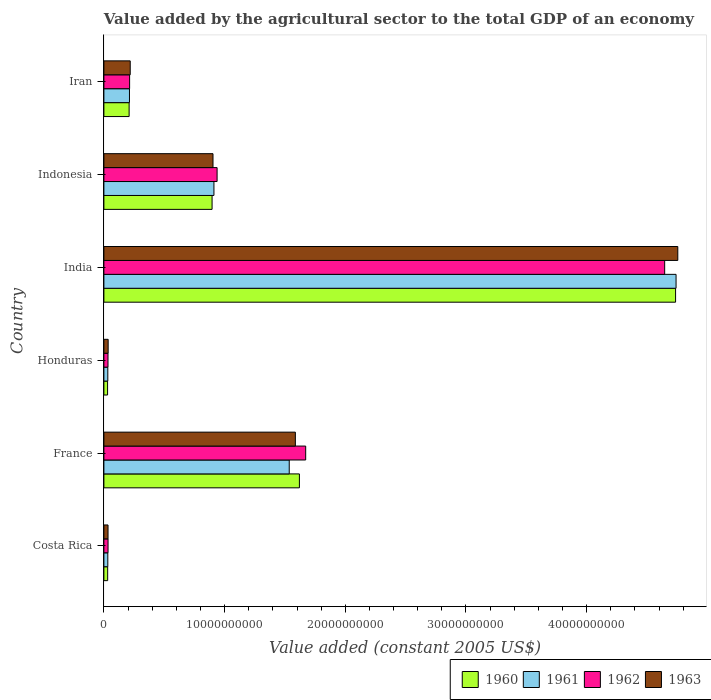How many groups of bars are there?
Offer a very short reply. 6. Are the number of bars on each tick of the Y-axis equal?
Your answer should be very brief. Yes. How many bars are there on the 6th tick from the top?
Your answer should be compact. 4. How many bars are there on the 4th tick from the bottom?
Your answer should be compact. 4. What is the label of the 3rd group of bars from the top?
Your answer should be compact. India. What is the value added by the agricultural sector in 1963 in Iran?
Provide a short and direct response. 2.18e+09. Across all countries, what is the maximum value added by the agricultural sector in 1962?
Offer a terse response. 4.65e+1. Across all countries, what is the minimum value added by the agricultural sector in 1963?
Your response must be concise. 3.43e+08. In which country was the value added by the agricultural sector in 1961 minimum?
Give a very brief answer. Costa Rica. What is the total value added by the agricultural sector in 1961 in the graph?
Your response must be concise. 7.47e+1. What is the difference between the value added by the agricultural sector in 1962 in India and that in Indonesia?
Provide a short and direct response. 3.71e+1. What is the difference between the value added by the agricultural sector in 1961 in Honduras and the value added by the agricultural sector in 1960 in Indonesia?
Offer a very short reply. -8.64e+09. What is the average value added by the agricultural sector in 1962 per country?
Your response must be concise. 1.26e+1. What is the difference between the value added by the agricultural sector in 1962 and value added by the agricultural sector in 1960 in Honduras?
Offer a very short reply. 3.54e+07. In how many countries, is the value added by the agricultural sector in 1963 greater than 8000000000 US$?
Ensure brevity in your answer.  3. What is the ratio of the value added by the agricultural sector in 1961 in Costa Rica to that in India?
Offer a terse response. 0.01. Is the difference between the value added by the agricultural sector in 1962 in Honduras and India greater than the difference between the value added by the agricultural sector in 1960 in Honduras and India?
Make the answer very short. Yes. What is the difference between the highest and the second highest value added by the agricultural sector in 1962?
Your answer should be compact. 2.97e+1. What is the difference between the highest and the lowest value added by the agricultural sector in 1962?
Provide a succinct answer. 4.61e+1. Is the sum of the value added by the agricultural sector in 1962 in Costa Rica and Indonesia greater than the maximum value added by the agricultural sector in 1961 across all countries?
Ensure brevity in your answer.  No. Is it the case that in every country, the sum of the value added by the agricultural sector in 1963 and value added by the agricultural sector in 1961 is greater than the sum of value added by the agricultural sector in 1962 and value added by the agricultural sector in 1960?
Provide a short and direct response. No. What does the 4th bar from the bottom in Costa Rica represents?
Keep it short and to the point. 1963. Is it the case that in every country, the sum of the value added by the agricultural sector in 1962 and value added by the agricultural sector in 1960 is greater than the value added by the agricultural sector in 1961?
Give a very brief answer. Yes. Are all the bars in the graph horizontal?
Keep it short and to the point. Yes. What is the difference between two consecutive major ticks on the X-axis?
Make the answer very short. 1.00e+1. Are the values on the major ticks of X-axis written in scientific E-notation?
Offer a very short reply. No. Does the graph contain any zero values?
Your answer should be compact. No. Does the graph contain grids?
Offer a terse response. No. Where does the legend appear in the graph?
Offer a terse response. Bottom right. How are the legend labels stacked?
Keep it short and to the point. Horizontal. What is the title of the graph?
Provide a succinct answer. Value added by the agricultural sector to the total GDP of an economy. Does "1999" appear as one of the legend labels in the graph?
Keep it short and to the point. No. What is the label or title of the X-axis?
Your answer should be compact. Value added (constant 2005 US$). What is the Value added (constant 2005 US$) of 1960 in Costa Rica?
Your answer should be compact. 3.13e+08. What is the Value added (constant 2005 US$) of 1961 in Costa Rica?
Make the answer very short. 3.24e+08. What is the Value added (constant 2005 US$) in 1962 in Costa Rica?
Provide a short and direct response. 3.44e+08. What is the Value added (constant 2005 US$) of 1963 in Costa Rica?
Ensure brevity in your answer.  3.43e+08. What is the Value added (constant 2005 US$) of 1960 in France?
Your response must be concise. 1.62e+1. What is the Value added (constant 2005 US$) in 1961 in France?
Offer a very short reply. 1.54e+1. What is the Value added (constant 2005 US$) of 1962 in France?
Provide a succinct answer. 1.67e+1. What is the Value added (constant 2005 US$) in 1963 in France?
Provide a succinct answer. 1.59e+1. What is the Value added (constant 2005 US$) of 1960 in Honduras?
Provide a succinct answer. 3.05e+08. What is the Value added (constant 2005 US$) in 1961 in Honduras?
Make the answer very short. 3.25e+08. What is the Value added (constant 2005 US$) in 1962 in Honduras?
Offer a terse response. 3.41e+08. What is the Value added (constant 2005 US$) of 1963 in Honduras?
Offer a very short reply. 3.53e+08. What is the Value added (constant 2005 US$) of 1960 in India?
Offer a terse response. 4.74e+1. What is the Value added (constant 2005 US$) of 1961 in India?
Keep it short and to the point. 4.74e+1. What is the Value added (constant 2005 US$) of 1962 in India?
Ensure brevity in your answer.  4.65e+1. What is the Value added (constant 2005 US$) of 1963 in India?
Keep it short and to the point. 4.76e+1. What is the Value added (constant 2005 US$) in 1960 in Indonesia?
Ensure brevity in your answer.  8.96e+09. What is the Value added (constant 2005 US$) in 1961 in Indonesia?
Offer a terse response. 9.12e+09. What is the Value added (constant 2005 US$) of 1962 in Indonesia?
Ensure brevity in your answer.  9.38e+09. What is the Value added (constant 2005 US$) in 1963 in Indonesia?
Give a very brief answer. 9.04e+09. What is the Value added (constant 2005 US$) in 1960 in Iran?
Offer a very short reply. 2.09e+09. What is the Value added (constant 2005 US$) in 1961 in Iran?
Provide a short and direct response. 2.12e+09. What is the Value added (constant 2005 US$) of 1962 in Iran?
Offer a terse response. 2.13e+09. What is the Value added (constant 2005 US$) in 1963 in Iran?
Provide a short and direct response. 2.18e+09. Across all countries, what is the maximum Value added (constant 2005 US$) in 1960?
Your response must be concise. 4.74e+1. Across all countries, what is the maximum Value added (constant 2005 US$) in 1961?
Ensure brevity in your answer.  4.74e+1. Across all countries, what is the maximum Value added (constant 2005 US$) in 1962?
Your answer should be very brief. 4.65e+1. Across all countries, what is the maximum Value added (constant 2005 US$) in 1963?
Your answer should be compact. 4.76e+1. Across all countries, what is the minimum Value added (constant 2005 US$) of 1960?
Your answer should be compact. 3.05e+08. Across all countries, what is the minimum Value added (constant 2005 US$) of 1961?
Your answer should be compact. 3.24e+08. Across all countries, what is the minimum Value added (constant 2005 US$) in 1962?
Ensure brevity in your answer.  3.41e+08. Across all countries, what is the minimum Value added (constant 2005 US$) in 1963?
Your response must be concise. 3.43e+08. What is the total Value added (constant 2005 US$) in 1960 in the graph?
Your answer should be very brief. 7.52e+1. What is the total Value added (constant 2005 US$) of 1961 in the graph?
Make the answer very short. 7.47e+1. What is the total Value added (constant 2005 US$) in 1962 in the graph?
Provide a succinct answer. 7.54e+1. What is the total Value added (constant 2005 US$) in 1963 in the graph?
Ensure brevity in your answer.  7.53e+1. What is the difference between the Value added (constant 2005 US$) of 1960 in Costa Rica and that in France?
Ensure brevity in your answer.  -1.59e+1. What is the difference between the Value added (constant 2005 US$) of 1961 in Costa Rica and that in France?
Provide a succinct answer. -1.50e+1. What is the difference between the Value added (constant 2005 US$) of 1962 in Costa Rica and that in France?
Provide a short and direct response. -1.64e+1. What is the difference between the Value added (constant 2005 US$) of 1963 in Costa Rica and that in France?
Your answer should be very brief. -1.55e+1. What is the difference between the Value added (constant 2005 US$) of 1960 in Costa Rica and that in Honduras?
Keep it short and to the point. 7.61e+06. What is the difference between the Value added (constant 2005 US$) in 1961 in Costa Rica and that in Honduras?
Provide a short and direct response. -8.14e+05. What is the difference between the Value added (constant 2005 US$) in 1962 in Costa Rica and that in Honduras?
Your answer should be compact. 3.61e+06. What is the difference between the Value added (constant 2005 US$) of 1963 in Costa Rica and that in Honduras?
Your answer should be compact. -9.78e+06. What is the difference between the Value added (constant 2005 US$) in 1960 in Costa Rica and that in India?
Your answer should be very brief. -4.71e+1. What is the difference between the Value added (constant 2005 US$) of 1961 in Costa Rica and that in India?
Give a very brief answer. -4.71e+1. What is the difference between the Value added (constant 2005 US$) in 1962 in Costa Rica and that in India?
Offer a very short reply. -4.61e+1. What is the difference between the Value added (constant 2005 US$) of 1963 in Costa Rica and that in India?
Make the answer very short. -4.72e+1. What is the difference between the Value added (constant 2005 US$) in 1960 in Costa Rica and that in Indonesia?
Your response must be concise. -8.65e+09. What is the difference between the Value added (constant 2005 US$) in 1961 in Costa Rica and that in Indonesia?
Provide a short and direct response. -8.79e+09. What is the difference between the Value added (constant 2005 US$) of 1962 in Costa Rica and that in Indonesia?
Give a very brief answer. -9.03e+09. What is the difference between the Value added (constant 2005 US$) in 1963 in Costa Rica and that in Indonesia?
Provide a short and direct response. -8.70e+09. What is the difference between the Value added (constant 2005 US$) of 1960 in Costa Rica and that in Iran?
Offer a terse response. -1.78e+09. What is the difference between the Value added (constant 2005 US$) in 1961 in Costa Rica and that in Iran?
Your answer should be very brief. -1.80e+09. What is the difference between the Value added (constant 2005 US$) in 1962 in Costa Rica and that in Iran?
Your answer should be very brief. -1.79e+09. What is the difference between the Value added (constant 2005 US$) of 1963 in Costa Rica and that in Iran?
Your answer should be compact. -1.84e+09. What is the difference between the Value added (constant 2005 US$) of 1960 in France and that in Honduras?
Your answer should be very brief. 1.59e+1. What is the difference between the Value added (constant 2005 US$) in 1961 in France and that in Honduras?
Provide a succinct answer. 1.50e+1. What is the difference between the Value added (constant 2005 US$) in 1962 in France and that in Honduras?
Provide a succinct answer. 1.64e+1. What is the difference between the Value added (constant 2005 US$) of 1963 in France and that in Honduras?
Ensure brevity in your answer.  1.55e+1. What is the difference between the Value added (constant 2005 US$) in 1960 in France and that in India?
Offer a terse response. -3.12e+1. What is the difference between the Value added (constant 2005 US$) in 1961 in France and that in India?
Offer a terse response. -3.21e+1. What is the difference between the Value added (constant 2005 US$) in 1962 in France and that in India?
Provide a short and direct response. -2.97e+1. What is the difference between the Value added (constant 2005 US$) of 1963 in France and that in India?
Keep it short and to the point. -3.17e+1. What is the difference between the Value added (constant 2005 US$) in 1960 in France and that in Indonesia?
Provide a succinct answer. 7.24e+09. What is the difference between the Value added (constant 2005 US$) of 1961 in France and that in Indonesia?
Your answer should be very brief. 6.24e+09. What is the difference between the Value added (constant 2005 US$) of 1962 in France and that in Indonesia?
Your answer should be compact. 7.34e+09. What is the difference between the Value added (constant 2005 US$) of 1963 in France and that in Indonesia?
Your response must be concise. 6.82e+09. What is the difference between the Value added (constant 2005 US$) in 1960 in France and that in Iran?
Offer a terse response. 1.41e+1. What is the difference between the Value added (constant 2005 US$) of 1961 in France and that in Iran?
Give a very brief answer. 1.32e+1. What is the difference between the Value added (constant 2005 US$) in 1962 in France and that in Iran?
Your answer should be very brief. 1.46e+1. What is the difference between the Value added (constant 2005 US$) of 1963 in France and that in Iran?
Give a very brief answer. 1.37e+1. What is the difference between the Value added (constant 2005 US$) in 1960 in Honduras and that in India?
Offer a terse response. -4.71e+1. What is the difference between the Value added (constant 2005 US$) of 1961 in Honduras and that in India?
Your answer should be compact. -4.71e+1. What is the difference between the Value added (constant 2005 US$) of 1962 in Honduras and that in India?
Keep it short and to the point. -4.61e+1. What is the difference between the Value added (constant 2005 US$) of 1963 in Honduras and that in India?
Offer a terse response. -4.72e+1. What is the difference between the Value added (constant 2005 US$) in 1960 in Honduras and that in Indonesia?
Your response must be concise. -8.66e+09. What is the difference between the Value added (constant 2005 US$) in 1961 in Honduras and that in Indonesia?
Ensure brevity in your answer.  -8.79e+09. What is the difference between the Value added (constant 2005 US$) of 1962 in Honduras and that in Indonesia?
Make the answer very short. -9.04e+09. What is the difference between the Value added (constant 2005 US$) of 1963 in Honduras and that in Indonesia?
Provide a succinct answer. -8.69e+09. What is the difference between the Value added (constant 2005 US$) of 1960 in Honduras and that in Iran?
Make the answer very short. -1.79e+09. What is the difference between the Value added (constant 2005 US$) of 1961 in Honduras and that in Iran?
Your answer should be compact. -1.79e+09. What is the difference between the Value added (constant 2005 US$) in 1962 in Honduras and that in Iran?
Your answer should be very brief. -1.79e+09. What is the difference between the Value added (constant 2005 US$) in 1963 in Honduras and that in Iran?
Give a very brief answer. -1.83e+09. What is the difference between the Value added (constant 2005 US$) of 1960 in India and that in Indonesia?
Your answer should be compact. 3.84e+1. What is the difference between the Value added (constant 2005 US$) in 1961 in India and that in Indonesia?
Ensure brevity in your answer.  3.83e+1. What is the difference between the Value added (constant 2005 US$) of 1962 in India and that in Indonesia?
Provide a short and direct response. 3.71e+1. What is the difference between the Value added (constant 2005 US$) of 1963 in India and that in Indonesia?
Ensure brevity in your answer.  3.85e+1. What is the difference between the Value added (constant 2005 US$) in 1960 in India and that in Iran?
Keep it short and to the point. 4.53e+1. What is the difference between the Value added (constant 2005 US$) in 1961 in India and that in Iran?
Offer a terse response. 4.53e+1. What is the difference between the Value added (constant 2005 US$) in 1962 in India and that in Iran?
Make the answer very short. 4.43e+1. What is the difference between the Value added (constant 2005 US$) of 1963 in India and that in Iran?
Ensure brevity in your answer.  4.54e+1. What is the difference between the Value added (constant 2005 US$) in 1960 in Indonesia and that in Iran?
Provide a succinct answer. 6.87e+09. What is the difference between the Value added (constant 2005 US$) in 1961 in Indonesia and that in Iran?
Provide a succinct answer. 7.00e+09. What is the difference between the Value added (constant 2005 US$) of 1962 in Indonesia and that in Iran?
Your answer should be compact. 7.25e+09. What is the difference between the Value added (constant 2005 US$) in 1963 in Indonesia and that in Iran?
Offer a very short reply. 6.86e+09. What is the difference between the Value added (constant 2005 US$) in 1960 in Costa Rica and the Value added (constant 2005 US$) in 1961 in France?
Offer a very short reply. -1.50e+1. What is the difference between the Value added (constant 2005 US$) in 1960 in Costa Rica and the Value added (constant 2005 US$) in 1962 in France?
Your response must be concise. -1.64e+1. What is the difference between the Value added (constant 2005 US$) of 1960 in Costa Rica and the Value added (constant 2005 US$) of 1963 in France?
Make the answer very short. -1.56e+1. What is the difference between the Value added (constant 2005 US$) of 1961 in Costa Rica and the Value added (constant 2005 US$) of 1962 in France?
Keep it short and to the point. -1.64e+1. What is the difference between the Value added (constant 2005 US$) in 1961 in Costa Rica and the Value added (constant 2005 US$) in 1963 in France?
Your response must be concise. -1.55e+1. What is the difference between the Value added (constant 2005 US$) of 1962 in Costa Rica and the Value added (constant 2005 US$) of 1963 in France?
Offer a very short reply. -1.55e+1. What is the difference between the Value added (constant 2005 US$) of 1960 in Costa Rica and the Value added (constant 2005 US$) of 1961 in Honduras?
Your answer should be compact. -1.23e+07. What is the difference between the Value added (constant 2005 US$) in 1960 in Costa Rica and the Value added (constant 2005 US$) in 1962 in Honduras?
Your response must be concise. -2.78e+07. What is the difference between the Value added (constant 2005 US$) in 1960 in Costa Rica and the Value added (constant 2005 US$) in 1963 in Honduras?
Provide a succinct answer. -4.02e+07. What is the difference between the Value added (constant 2005 US$) in 1961 in Costa Rica and the Value added (constant 2005 US$) in 1962 in Honduras?
Make the answer very short. -1.63e+07. What is the difference between the Value added (constant 2005 US$) of 1961 in Costa Rica and the Value added (constant 2005 US$) of 1963 in Honduras?
Offer a terse response. -2.87e+07. What is the difference between the Value added (constant 2005 US$) in 1962 in Costa Rica and the Value added (constant 2005 US$) in 1963 in Honduras?
Your answer should be very brief. -8.78e+06. What is the difference between the Value added (constant 2005 US$) of 1960 in Costa Rica and the Value added (constant 2005 US$) of 1961 in India?
Make the answer very short. -4.71e+1. What is the difference between the Value added (constant 2005 US$) of 1960 in Costa Rica and the Value added (constant 2005 US$) of 1962 in India?
Give a very brief answer. -4.62e+1. What is the difference between the Value added (constant 2005 US$) of 1960 in Costa Rica and the Value added (constant 2005 US$) of 1963 in India?
Give a very brief answer. -4.72e+1. What is the difference between the Value added (constant 2005 US$) of 1961 in Costa Rica and the Value added (constant 2005 US$) of 1962 in India?
Offer a very short reply. -4.61e+1. What is the difference between the Value added (constant 2005 US$) of 1961 in Costa Rica and the Value added (constant 2005 US$) of 1963 in India?
Provide a short and direct response. -4.72e+1. What is the difference between the Value added (constant 2005 US$) of 1962 in Costa Rica and the Value added (constant 2005 US$) of 1963 in India?
Give a very brief answer. -4.72e+1. What is the difference between the Value added (constant 2005 US$) in 1960 in Costa Rica and the Value added (constant 2005 US$) in 1961 in Indonesia?
Offer a very short reply. -8.80e+09. What is the difference between the Value added (constant 2005 US$) in 1960 in Costa Rica and the Value added (constant 2005 US$) in 1962 in Indonesia?
Your response must be concise. -9.07e+09. What is the difference between the Value added (constant 2005 US$) of 1960 in Costa Rica and the Value added (constant 2005 US$) of 1963 in Indonesia?
Ensure brevity in your answer.  -8.73e+09. What is the difference between the Value added (constant 2005 US$) in 1961 in Costa Rica and the Value added (constant 2005 US$) in 1962 in Indonesia?
Your answer should be compact. -9.05e+09. What is the difference between the Value added (constant 2005 US$) of 1961 in Costa Rica and the Value added (constant 2005 US$) of 1963 in Indonesia?
Ensure brevity in your answer.  -8.72e+09. What is the difference between the Value added (constant 2005 US$) of 1962 in Costa Rica and the Value added (constant 2005 US$) of 1963 in Indonesia?
Your response must be concise. -8.70e+09. What is the difference between the Value added (constant 2005 US$) in 1960 in Costa Rica and the Value added (constant 2005 US$) in 1961 in Iran?
Give a very brief answer. -1.81e+09. What is the difference between the Value added (constant 2005 US$) in 1960 in Costa Rica and the Value added (constant 2005 US$) in 1962 in Iran?
Make the answer very short. -1.82e+09. What is the difference between the Value added (constant 2005 US$) in 1960 in Costa Rica and the Value added (constant 2005 US$) in 1963 in Iran?
Offer a very short reply. -1.87e+09. What is the difference between the Value added (constant 2005 US$) in 1961 in Costa Rica and the Value added (constant 2005 US$) in 1962 in Iran?
Offer a very short reply. -1.81e+09. What is the difference between the Value added (constant 2005 US$) in 1961 in Costa Rica and the Value added (constant 2005 US$) in 1963 in Iran?
Provide a short and direct response. -1.86e+09. What is the difference between the Value added (constant 2005 US$) of 1962 in Costa Rica and the Value added (constant 2005 US$) of 1963 in Iran?
Your response must be concise. -1.84e+09. What is the difference between the Value added (constant 2005 US$) in 1960 in France and the Value added (constant 2005 US$) in 1961 in Honduras?
Ensure brevity in your answer.  1.59e+1. What is the difference between the Value added (constant 2005 US$) of 1960 in France and the Value added (constant 2005 US$) of 1962 in Honduras?
Give a very brief answer. 1.59e+1. What is the difference between the Value added (constant 2005 US$) in 1960 in France and the Value added (constant 2005 US$) in 1963 in Honduras?
Ensure brevity in your answer.  1.58e+1. What is the difference between the Value added (constant 2005 US$) in 1961 in France and the Value added (constant 2005 US$) in 1962 in Honduras?
Keep it short and to the point. 1.50e+1. What is the difference between the Value added (constant 2005 US$) of 1961 in France and the Value added (constant 2005 US$) of 1963 in Honduras?
Offer a very short reply. 1.50e+1. What is the difference between the Value added (constant 2005 US$) of 1962 in France and the Value added (constant 2005 US$) of 1963 in Honduras?
Offer a very short reply. 1.64e+1. What is the difference between the Value added (constant 2005 US$) of 1960 in France and the Value added (constant 2005 US$) of 1961 in India?
Your answer should be very brief. -3.12e+1. What is the difference between the Value added (constant 2005 US$) of 1960 in France and the Value added (constant 2005 US$) of 1962 in India?
Your response must be concise. -3.03e+1. What is the difference between the Value added (constant 2005 US$) of 1960 in France and the Value added (constant 2005 US$) of 1963 in India?
Keep it short and to the point. -3.14e+1. What is the difference between the Value added (constant 2005 US$) of 1961 in France and the Value added (constant 2005 US$) of 1962 in India?
Offer a very short reply. -3.11e+1. What is the difference between the Value added (constant 2005 US$) of 1961 in France and the Value added (constant 2005 US$) of 1963 in India?
Your answer should be compact. -3.22e+1. What is the difference between the Value added (constant 2005 US$) of 1962 in France and the Value added (constant 2005 US$) of 1963 in India?
Your answer should be compact. -3.08e+1. What is the difference between the Value added (constant 2005 US$) of 1960 in France and the Value added (constant 2005 US$) of 1961 in Indonesia?
Provide a succinct answer. 7.08e+09. What is the difference between the Value added (constant 2005 US$) in 1960 in France and the Value added (constant 2005 US$) in 1962 in Indonesia?
Offer a very short reply. 6.82e+09. What is the difference between the Value added (constant 2005 US$) in 1960 in France and the Value added (constant 2005 US$) in 1963 in Indonesia?
Offer a terse response. 7.16e+09. What is the difference between the Value added (constant 2005 US$) of 1961 in France and the Value added (constant 2005 US$) of 1962 in Indonesia?
Make the answer very short. 5.98e+09. What is the difference between the Value added (constant 2005 US$) in 1961 in France and the Value added (constant 2005 US$) in 1963 in Indonesia?
Offer a very short reply. 6.32e+09. What is the difference between the Value added (constant 2005 US$) in 1962 in France and the Value added (constant 2005 US$) in 1963 in Indonesia?
Offer a terse response. 7.68e+09. What is the difference between the Value added (constant 2005 US$) in 1960 in France and the Value added (constant 2005 US$) in 1961 in Iran?
Offer a terse response. 1.41e+1. What is the difference between the Value added (constant 2005 US$) in 1960 in France and the Value added (constant 2005 US$) in 1962 in Iran?
Your answer should be compact. 1.41e+1. What is the difference between the Value added (constant 2005 US$) in 1960 in France and the Value added (constant 2005 US$) in 1963 in Iran?
Ensure brevity in your answer.  1.40e+1. What is the difference between the Value added (constant 2005 US$) in 1961 in France and the Value added (constant 2005 US$) in 1962 in Iran?
Your answer should be very brief. 1.32e+1. What is the difference between the Value added (constant 2005 US$) of 1961 in France and the Value added (constant 2005 US$) of 1963 in Iran?
Give a very brief answer. 1.32e+1. What is the difference between the Value added (constant 2005 US$) in 1962 in France and the Value added (constant 2005 US$) in 1963 in Iran?
Offer a very short reply. 1.45e+1. What is the difference between the Value added (constant 2005 US$) of 1960 in Honduras and the Value added (constant 2005 US$) of 1961 in India?
Your response must be concise. -4.71e+1. What is the difference between the Value added (constant 2005 US$) of 1960 in Honduras and the Value added (constant 2005 US$) of 1962 in India?
Offer a very short reply. -4.62e+1. What is the difference between the Value added (constant 2005 US$) of 1960 in Honduras and the Value added (constant 2005 US$) of 1963 in India?
Give a very brief answer. -4.72e+1. What is the difference between the Value added (constant 2005 US$) in 1961 in Honduras and the Value added (constant 2005 US$) in 1962 in India?
Provide a succinct answer. -4.61e+1. What is the difference between the Value added (constant 2005 US$) in 1961 in Honduras and the Value added (constant 2005 US$) in 1963 in India?
Your answer should be compact. -4.72e+1. What is the difference between the Value added (constant 2005 US$) in 1962 in Honduras and the Value added (constant 2005 US$) in 1963 in India?
Offer a very short reply. -4.72e+1. What is the difference between the Value added (constant 2005 US$) in 1960 in Honduras and the Value added (constant 2005 US$) in 1961 in Indonesia?
Give a very brief answer. -8.81e+09. What is the difference between the Value added (constant 2005 US$) in 1960 in Honduras and the Value added (constant 2005 US$) in 1962 in Indonesia?
Offer a very short reply. -9.07e+09. What is the difference between the Value added (constant 2005 US$) of 1960 in Honduras and the Value added (constant 2005 US$) of 1963 in Indonesia?
Keep it short and to the point. -8.73e+09. What is the difference between the Value added (constant 2005 US$) of 1961 in Honduras and the Value added (constant 2005 US$) of 1962 in Indonesia?
Make the answer very short. -9.05e+09. What is the difference between the Value added (constant 2005 US$) of 1961 in Honduras and the Value added (constant 2005 US$) of 1963 in Indonesia?
Your answer should be compact. -8.72e+09. What is the difference between the Value added (constant 2005 US$) in 1962 in Honduras and the Value added (constant 2005 US$) in 1963 in Indonesia?
Provide a succinct answer. -8.70e+09. What is the difference between the Value added (constant 2005 US$) in 1960 in Honduras and the Value added (constant 2005 US$) in 1961 in Iran?
Make the answer very short. -1.81e+09. What is the difference between the Value added (constant 2005 US$) of 1960 in Honduras and the Value added (constant 2005 US$) of 1962 in Iran?
Offer a terse response. -1.82e+09. What is the difference between the Value added (constant 2005 US$) in 1960 in Honduras and the Value added (constant 2005 US$) in 1963 in Iran?
Your answer should be very brief. -1.88e+09. What is the difference between the Value added (constant 2005 US$) in 1961 in Honduras and the Value added (constant 2005 US$) in 1962 in Iran?
Ensure brevity in your answer.  -1.80e+09. What is the difference between the Value added (constant 2005 US$) of 1961 in Honduras and the Value added (constant 2005 US$) of 1963 in Iran?
Offer a terse response. -1.86e+09. What is the difference between the Value added (constant 2005 US$) of 1962 in Honduras and the Value added (constant 2005 US$) of 1963 in Iran?
Your answer should be compact. -1.84e+09. What is the difference between the Value added (constant 2005 US$) in 1960 in India and the Value added (constant 2005 US$) in 1961 in Indonesia?
Keep it short and to the point. 3.83e+1. What is the difference between the Value added (constant 2005 US$) in 1960 in India and the Value added (constant 2005 US$) in 1962 in Indonesia?
Keep it short and to the point. 3.80e+1. What is the difference between the Value added (constant 2005 US$) of 1960 in India and the Value added (constant 2005 US$) of 1963 in Indonesia?
Keep it short and to the point. 3.83e+1. What is the difference between the Value added (constant 2005 US$) of 1961 in India and the Value added (constant 2005 US$) of 1962 in Indonesia?
Your answer should be very brief. 3.80e+1. What is the difference between the Value added (constant 2005 US$) of 1961 in India and the Value added (constant 2005 US$) of 1963 in Indonesia?
Provide a short and direct response. 3.84e+1. What is the difference between the Value added (constant 2005 US$) in 1962 in India and the Value added (constant 2005 US$) in 1963 in Indonesia?
Provide a succinct answer. 3.74e+1. What is the difference between the Value added (constant 2005 US$) in 1960 in India and the Value added (constant 2005 US$) in 1961 in Iran?
Offer a very short reply. 4.52e+1. What is the difference between the Value added (constant 2005 US$) of 1960 in India and the Value added (constant 2005 US$) of 1962 in Iran?
Offer a terse response. 4.52e+1. What is the difference between the Value added (constant 2005 US$) in 1960 in India and the Value added (constant 2005 US$) in 1963 in Iran?
Your answer should be very brief. 4.52e+1. What is the difference between the Value added (constant 2005 US$) in 1961 in India and the Value added (constant 2005 US$) in 1962 in Iran?
Your answer should be compact. 4.53e+1. What is the difference between the Value added (constant 2005 US$) of 1961 in India and the Value added (constant 2005 US$) of 1963 in Iran?
Give a very brief answer. 4.52e+1. What is the difference between the Value added (constant 2005 US$) in 1962 in India and the Value added (constant 2005 US$) in 1963 in Iran?
Provide a succinct answer. 4.43e+1. What is the difference between the Value added (constant 2005 US$) of 1960 in Indonesia and the Value added (constant 2005 US$) of 1961 in Iran?
Offer a very short reply. 6.84e+09. What is the difference between the Value added (constant 2005 US$) of 1960 in Indonesia and the Value added (constant 2005 US$) of 1962 in Iran?
Make the answer very short. 6.83e+09. What is the difference between the Value added (constant 2005 US$) in 1960 in Indonesia and the Value added (constant 2005 US$) in 1963 in Iran?
Your answer should be compact. 6.78e+09. What is the difference between the Value added (constant 2005 US$) in 1961 in Indonesia and the Value added (constant 2005 US$) in 1962 in Iran?
Your answer should be very brief. 6.99e+09. What is the difference between the Value added (constant 2005 US$) of 1961 in Indonesia and the Value added (constant 2005 US$) of 1963 in Iran?
Provide a succinct answer. 6.94e+09. What is the difference between the Value added (constant 2005 US$) in 1962 in Indonesia and the Value added (constant 2005 US$) in 1963 in Iran?
Your answer should be compact. 7.20e+09. What is the average Value added (constant 2005 US$) in 1960 per country?
Make the answer very short. 1.25e+1. What is the average Value added (constant 2005 US$) of 1961 per country?
Offer a terse response. 1.24e+1. What is the average Value added (constant 2005 US$) in 1962 per country?
Offer a terse response. 1.26e+1. What is the average Value added (constant 2005 US$) in 1963 per country?
Your answer should be compact. 1.26e+1. What is the difference between the Value added (constant 2005 US$) of 1960 and Value added (constant 2005 US$) of 1961 in Costa Rica?
Make the answer very short. -1.15e+07. What is the difference between the Value added (constant 2005 US$) in 1960 and Value added (constant 2005 US$) in 1962 in Costa Rica?
Make the answer very short. -3.14e+07. What is the difference between the Value added (constant 2005 US$) of 1960 and Value added (constant 2005 US$) of 1963 in Costa Rica?
Give a very brief answer. -3.04e+07. What is the difference between the Value added (constant 2005 US$) of 1961 and Value added (constant 2005 US$) of 1962 in Costa Rica?
Provide a short and direct response. -1.99e+07. What is the difference between the Value added (constant 2005 US$) of 1961 and Value added (constant 2005 US$) of 1963 in Costa Rica?
Your answer should be very brief. -1.89e+07. What is the difference between the Value added (constant 2005 US$) in 1962 and Value added (constant 2005 US$) in 1963 in Costa Rica?
Your answer should be very brief. 1.00e+06. What is the difference between the Value added (constant 2005 US$) of 1960 and Value added (constant 2005 US$) of 1961 in France?
Offer a very short reply. 8.42e+08. What is the difference between the Value added (constant 2005 US$) of 1960 and Value added (constant 2005 US$) of 1962 in France?
Offer a very short reply. -5.20e+08. What is the difference between the Value added (constant 2005 US$) of 1960 and Value added (constant 2005 US$) of 1963 in France?
Your response must be concise. 3.35e+08. What is the difference between the Value added (constant 2005 US$) in 1961 and Value added (constant 2005 US$) in 1962 in France?
Give a very brief answer. -1.36e+09. What is the difference between the Value added (constant 2005 US$) in 1961 and Value added (constant 2005 US$) in 1963 in France?
Provide a succinct answer. -5.07e+08. What is the difference between the Value added (constant 2005 US$) of 1962 and Value added (constant 2005 US$) of 1963 in France?
Your answer should be compact. 8.56e+08. What is the difference between the Value added (constant 2005 US$) in 1960 and Value added (constant 2005 US$) in 1961 in Honduras?
Offer a very short reply. -1.99e+07. What is the difference between the Value added (constant 2005 US$) of 1960 and Value added (constant 2005 US$) of 1962 in Honduras?
Offer a terse response. -3.54e+07. What is the difference between the Value added (constant 2005 US$) in 1960 and Value added (constant 2005 US$) in 1963 in Honduras?
Offer a terse response. -4.78e+07. What is the difference between the Value added (constant 2005 US$) of 1961 and Value added (constant 2005 US$) of 1962 in Honduras?
Provide a short and direct response. -1.55e+07. What is the difference between the Value added (constant 2005 US$) in 1961 and Value added (constant 2005 US$) in 1963 in Honduras?
Your answer should be compact. -2.79e+07. What is the difference between the Value added (constant 2005 US$) in 1962 and Value added (constant 2005 US$) in 1963 in Honduras?
Keep it short and to the point. -1.24e+07. What is the difference between the Value added (constant 2005 US$) of 1960 and Value added (constant 2005 US$) of 1961 in India?
Give a very brief answer. -3.99e+07. What is the difference between the Value added (constant 2005 US$) in 1960 and Value added (constant 2005 US$) in 1962 in India?
Ensure brevity in your answer.  9.03e+08. What is the difference between the Value added (constant 2005 US$) in 1960 and Value added (constant 2005 US$) in 1963 in India?
Provide a succinct answer. -1.84e+08. What is the difference between the Value added (constant 2005 US$) in 1961 and Value added (constant 2005 US$) in 1962 in India?
Ensure brevity in your answer.  9.43e+08. What is the difference between the Value added (constant 2005 US$) in 1961 and Value added (constant 2005 US$) in 1963 in India?
Make the answer very short. -1.44e+08. What is the difference between the Value added (constant 2005 US$) in 1962 and Value added (constant 2005 US$) in 1963 in India?
Your response must be concise. -1.09e+09. What is the difference between the Value added (constant 2005 US$) of 1960 and Value added (constant 2005 US$) of 1961 in Indonesia?
Provide a succinct answer. -1.54e+08. What is the difference between the Value added (constant 2005 US$) of 1960 and Value added (constant 2005 US$) of 1962 in Indonesia?
Offer a terse response. -4.16e+08. What is the difference between the Value added (constant 2005 US$) in 1960 and Value added (constant 2005 US$) in 1963 in Indonesia?
Offer a terse response. -7.71e+07. What is the difference between the Value added (constant 2005 US$) of 1961 and Value added (constant 2005 US$) of 1962 in Indonesia?
Make the answer very short. -2.62e+08. What is the difference between the Value added (constant 2005 US$) in 1961 and Value added (constant 2005 US$) in 1963 in Indonesia?
Your answer should be very brief. 7.71e+07. What is the difference between the Value added (constant 2005 US$) of 1962 and Value added (constant 2005 US$) of 1963 in Indonesia?
Ensure brevity in your answer.  3.39e+08. What is the difference between the Value added (constant 2005 US$) in 1960 and Value added (constant 2005 US$) in 1961 in Iran?
Provide a succinct answer. -2.84e+07. What is the difference between the Value added (constant 2005 US$) of 1960 and Value added (constant 2005 US$) of 1962 in Iran?
Give a very brief answer. -3.89e+07. What is the difference between the Value added (constant 2005 US$) of 1960 and Value added (constant 2005 US$) of 1963 in Iran?
Your response must be concise. -9.02e+07. What is the difference between the Value added (constant 2005 US$) in 1961 and Value added (constant 2005 US$) in 1962 in Iran?
Your answer should be very brief. -1.05e+07. What is the difference between the Value added (constant 2005 US$) of 1961 and Value added (constant 2005 US$) of 1963 in Iran?
Provide a succinct answer. -6.18e+07. What is the difference between the Value added (constant 2005 US$) of 1962 and Value added (constant 2005 US$) of 1963 in Iran?
Make the answer very short. -5.13e+07. What is the ratio of the Value added (constant 2005 US$) of 1960 in Costa Rica to that in France?
Your answer should be compact. 0.02. What is the ratio of the Value added (constant 2005 US$) of 1961 in Costa Rica to that in France?
Ensure brevity in your answer.  0.02. What is the ratio of the Value added (constant 2005 US$) in 1962 in Costa Rica to that in France?
Your answer should be very brief. 0.02. What is the ratio of the Value added (constant 2005 US$) of 1963 in Costa Rica to that in France?
Offer a very short reply. 0.02. What is the ratio of the Value added (constant 2005 US$) in 1960 in Costa Rica to that in Honduras?
Your answer should be very brief. 1.02. What is the ratio of the Value added (constant 2005 US$) in 1962 in Costa Rica to that in Honduras?
Your response must be concise. 1.01. What is the ratio of the Value added (constant 2005 US$) in 1963 in Costa Rica to that in Honduras?
Provide a succinct answer. 0.97. What is the ratio of the Value added (constant 2005 US$) of 1960 in Costa Rica to that in India?
Offer a terse response. 0.01. What is the ratio of the Value added (constant 2005 US$) in 1961 in Costa Rica to that in India?
Your response must be concise. 0.01. What is the ratio of the Value added (constant 2005 US$) of 1962 in Costa Rica to that in India?
Provide a short and direct response. 0.01. What is the ratio of the Value added (constant 2005 US$) of 1963 in Costa Rica to that in India?
Your answer should be very brief. 0.01. What is the ratio of the Value added (constant 2005 US$) of 1960 in Costa Rica to that in Indonesia?
Give a very brief answer. 0.03. What is the ratio of the Value added (constant 2005 US$) of 1961 in Costa Rica to that in Indonesia?
Provide a succinct answer. 0.04. What is the ratio of the Value added (constant 2005 US$) in 1962 in Costa Rica to that in Indonesia?
Ensure brevity in your answer.  0.04. What is the ratio of the Value added (constant 2005 US$) in 1963 in Costa Rica to that in Indonesia?
Your answer should be very brief. 0.04. What is the ratio of the Value added (constant 2005 US$) of 1960 in Costa Rica to that in Iran?
Offer a terse response. 0.15. What is the ratio of the Value added (constant 2005 US$) of 1961 in Costa Rica to that in Iran?
Your answer should be compact. 0.15. What is the ratio of the Value added (constant 2005 US$) of 1962 in Costa Rica to that in Iran?
Your response must be concise. 0.16. What is the ratio of the Value added (constant 2005 US$) in 1963 in Costa Rica to that in Iran?
Your answer should be compact. 0.16. What is the ratio of the Value added (constant 2005 US$) of 1960 in France to that in Honduras?
Offer a terse response. 53.05. What is the ratio of the Value added (constant 2005 US$) in 1961 in France to that in Honduras?
Your answer should be very brief. 47.21. What is the ratio of the Value added (constant 2005 US$) of 1962 in France to that in Honduras?
Make the answer very short. 49.07. What is the ratio of the Value added (constant 2005 US$) of 1963 in France to that in Honduras?
Your response must be concise. 44.92. What is the ratio of the Value added (constant 2005 US$) of 1960 in France to that in India?
Your response must be concise. 0.34. What is the ratio of the Value added (constant 2005 US$) in 1961 in France to that in India?
Ensure brevity in your answer.  0.32. What is the ratio of the Value added (constant 2005 US$) of 1962 in France to that in India?
Offer a terse response. 0.36. What is the ratio of the Value added (constant 2005 US$) in 1963 in France to that in India?
Offer a very short reply. 0.33. What is the ratio of the Value added (constant 2005 US$) of 1960 in France to that in Indonesia?
Ensure brevity in your answer.  1.81. What is the ratio of the Value added (constant 2005 US$) in 1961 in France to that in Indonesia?
Keep it short and to the point. 1.68. What is the ratio of the Value added (constant 2005 US$) in 1962 in France to that in Indonesia?
Keep it short and to the point. 1.78. What is the ratio of the Value added (constant 2005 US$) of 1963 in France to that in Indonesia?
Make the answer very short. 1.75. What is the ratio of the Value added (constant 2005 US$) of 1960 in France to that in Iran?
Offer a very short reply. 7.75. What is the ratio of the Value added (constant 2005 US$) in 1961 in France to that in Iran?
Provide a succinct answer. 7.24. What is the ratio of the Value added (constant 2005 US$) in 1962 in France to that in Iran?
Give a very brief answer. 7.85. What is the ratio of the Value added (constant 2005 US$) in 1963 in France to that in Iran?
Offer a very short reply. 7.27. What is the ratio of the Value added (constant 2005 US$) in 1960 in Honduras to that in India?
Offer a terse response. 0.01. What is the ratio of the Value added (constant 2005 US$) in 1961 in Honduras to that in India?
Your answer should be compact. 0.01. What is the ratio of the Value added (constant 2005 US$) of 1962 in Honduras to that in India?
Ensure brevity in your answer.  0.01. What is the ratio of the Value added (constant 2005 US$) in 1963 in Honduras to that in India?
Your answer should be very brief. 0.01. What is the ratio of the Value added (constant 2005 US$) in 1960 in Honduras to that in Indonesia?
Keep it short and to the point. 0.03. What is the ratio of the Value added (constant 2005 US$) in 1961 in Honduras to that in Indonesia?
Your answer should be compact. 0.04. What is the ratio of the Value added (constant 2005 US$) in 1962 in Honduras to that in Indonesia?
Offer a terse response. 0.04. What is the ratio of the Value added (constant 2005 US$) in 1963 in Honduras to that in Indonesia?
Your response must be concise. 0.04. What is the ratio of the Value added (constant 2005 US$) in 1960 in Honduras to that in Iran?
Offer a terse response. 0.15. What is the ratio of the Value added (constant 2005 US$) of 1961 in Honduras to that in Iran?
Offer a terse response. 0.15. What is the ratio of the Value added (constant 2005 US$) of 1962 in Honduras to that in Iran?
Ensure brevity in your answer.  0.16. What is the ratio of the Value added (constant 2005 US$) of 1963 in Honduras to that in Iran?
Offer a very short reply. 0.16. What is the ratio of the Value added (constant 2005 US$) in 1960 in India to that in Indonesia?
Offer a terse response. 5.28. What is the ratio of the Value added (constant 2005 US$) in 1961 in India to that in Indonesia?
Give a very brief answer. 5.2. What is the ratio of the Value added (constant 2005 US$) of 1962 in India to that in Indonesia?
Provide a short and direct response. 4.95. What is the ratio of the Value added (constant 2005 US$) of 1963 in India to that in Indonesia?
Your response must be concise. 5.26. What is the ratio of the Value added (constant 2005 US$) in 1960 in India to that in Iran?
Provide a short and direct response. 22.65. What is the ratio of the Value added (constant 2005 US$) in 1961 in India to that in Iran?
Offer a terse response. 22.37. What is the ratio of the Value added (constant 2005 US$) in 1962 in India to that in Iran?
Give a very brief answer. 21.81. What is the ratio of the Value added (constant 2005 US$) of 1963 in India to that in Iran?
Offer a terse response. 21.8. What is the ratio of the Value added (constant 2005 US$) in 1960 in Indonesia to that in Iran?
Provide a succinct answer. 4.29. What is the ratio of the Value added (constant 2005 US$) in 1961 in Indonesia to that in Iran?
Ensure brevity in your answer.  4.3. What is the ratio of the Value added (constant 2005 US$) in 1962 in Indonesia to that in Iran?
Your answer should be compact. 4.4. What is the ratio of the Value added (constant 2005 US$) in 1963 in Indonesia to that in Iran?
Offer a terse response. 4.14. What is the difference between the highest and the second highest Value added (constant 2005 US$) of 1960?
Your answer should be very brief. 3.12e+1. What is the difference between the highest and the second highest Value added (constant 2005 US$) of 1961?
Your response must be concise. 3.21e+1. What is the difference between the highest and the second highest Value added (constant 2005 US$) of 1962?
Your answer should be very brief. 2.97e+1. What is the difference between the highest and the second highest Value added (constant 2005 US$) of 1963?
Give a very brief answer. 3.17e+1. What is the difference between the highest and the lowest Value added (constant 2005 US$) in 1960?
Keep it short and to the point. 4.71e+1. What is the difference between the highest and the lowest Value added (constant 2005 US$) of 1961?
Your answer should be compact. 4.71e+1. What is the difference between the highest and the lowest Value added (constant 2005 US$) in 1962?
Ensure brevity in your answer.  4.61e+1. What is the difference between the highest and the lowest Value added (constant 2005 US$) in 1963?
Make the answer very short. 4.72e+1. 